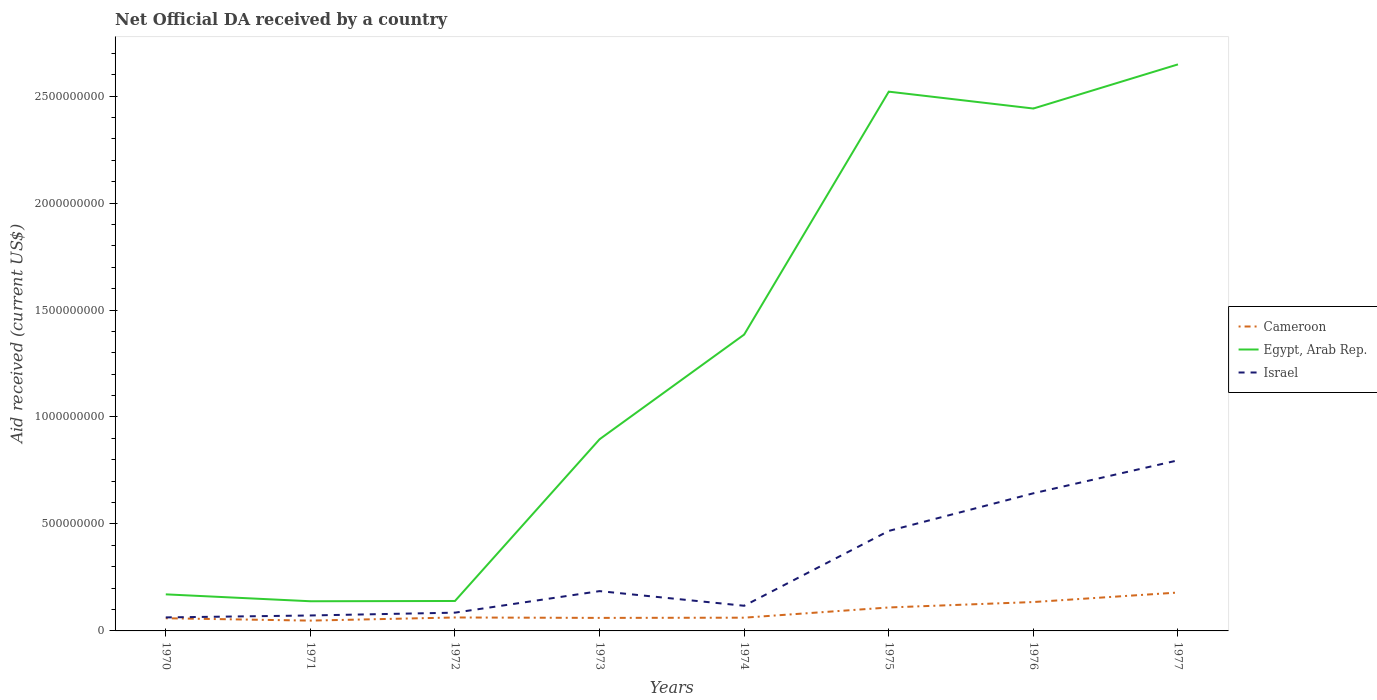Does the line corresponding to Egypt, Arab Rep. intersect with the line corresponding to Israel?
Provide a succinct answer. No. Is the number of lines equal to the number of legend labels?
Offer a very short reply. Yes. Across all years, what is the maximum net official development assistance aid received in Israel?
Offer a terse response. 6.32e+07. What is the total net official development assistance aid received in Cameroon in the graph?
Keep it short and to the point. -3.59e+06. What is the difference between the highest and the second highest net official development assistance aid received in Israel?
Provide a short and direct response. 7.34e+08. How many years are there in the graph?
Offer a very short reply. 8. Are the values on the major ticks of Y-axis written in scientific E-notation?
Make the answer very short. No. What is the title of the graph?
Your response must be concise. Net Official DA received by a country. What is the label or title of the Y-axis?
Offer a terse response. Aid received (current US$). What is the Aid received (current US$) in Cameroon in 1970?
Ensure brevity in your answer.  5.93e+07. What is the Aid received (current US$) of Egypt, Arab Rep. in 1970?
Give a very brief answer. 1.71e+08. What is the Aid received (current US$) of Israel in 1970?
Provide a succinct answer. 6.32e+07. What is the Aid received (current US$) of Cameroon in 1971?
Offer a very short reply. 4.82e+07. What is the Aid received (current US$) in Egypt, Arab Rep. in 1971?
Make the answer very short. 1.39e+08. What is the Aid received (current US$) in Israel in 1971?
Your answer should be compact. 7.22e+07. What is the Aid received (current US$) of Cameroon in 1972?
Provide a succinct answer. 6.29e+07. What is the Aid received (current US$) of Egypt, Arab Rep. in 1972?
Your answer should be very brief. 1.40e+08. What is the Aid received (current US$) of Israel in 1972?
Provide a short and direct response. 8.54e+07. What is the Aid received (current US$) in Cameroon in 1973?
Offer a very short reply. 6.09e+07. What is the Aid received (current US$) of Egypt, Arab Rep. in 1973?
Provide a short and direct response. 8.96e+08. What is the Aid received (current US$) in Israel in 1973?
Ensure brevity in your answer.  1.86e+08. What is the Aid received (current US$) in Cameroon in 1974?
Offer a terse response. 6.19e+07. What is the Aid received (current US$) in Egypt, Arab Rep. in 1974?
Provide a short and direct response. 1.39e+09. What is the Aid received (current US$) in Israel in 1974?
Your response must be concise. 1.18e+08. What is the Aid received (current US$) in Cameroon in 1975?
Keep it short and to the point. 1.10e+08. What is the Aid received (current US$) of Egypt, Arab Rep. in 1975?
Offer a very short reply. 2.52e+09. What is the Aid received (current US$) in Israel in 1975?
Keep it short and to the point. 4.67e+08. What is the Aid received (current US$) of Cameroon in 1976?
Keep it short and to the point. 1.35e+08. What is the Aid received (current US$) of Egypt, Arab Rep. in 1976?
Your answer should be compact. 2.44e+09. What is the Aid received (current US$) of Israel in 1976?
Give a very brief answer. 6.43e+08. What is the Aid received (current US$) in Cameroon in 1977?
Make the answer very short. 1.79e+08. What is the Aid received (current US$) of Egypt, Arab Rep. in 1977?
Offer a very short reply. 2.65e+09. What is the Aid received (current US$) of Israel in 1977?
Your answer should be very brief. 7.97e+08. Across all years, what is the maximum Aid received (current US$) in Cameroon?
Ensure brevity in your answer.  1.79e+08. Across all years, what is the maximum Aid received (current US$) in Egypt, Arab Rep.?
Your response must be concise. 2.65e+09. Across all years, what is the maximum Aid received (current US$) in Israel?
Make the answer very short. 7.97e+08. Across all years, what is the minimum Aid received (current US$) of Cameroon?
Make the answer very short. 4.82e+07. Across all years, what is the minimum Aid received (current US$) in Egypt, Arab Rep.?
Ensure brevity in your answer.  1.39e+08. Across all years, what is the minimum Aid received (current US$) of Israel?
Your response must be concise. 6.32e+07. What is the total Aid received (current US$) in Cameroon in the graph?
Ensure brevity in your answer.  7.17e+08. What is the total Aid received (current US$) of Egypt, Arab Rep. in the graph?
Keep it short and to the point. 1.03e+1. What is the total Aid received (current US$) in Israel in the graph?
Your response must be concise. 2.43e+09. What is the difference between the Aid received (current US$) in Cameroon in 1970 and that in 1971?
Offer a very short reply. 1.11e+07. What is the difference between the Aid received (current US$) of Egypt, Arab Rep. in 1970 and that in 1971?
Ensure brevity in your answer.  3.22e+07. What is the difference between the Aid received (current US$) of Israel in 1970 and that in 1971?
Offer a very short reply. -9.06e+06. What is the difference between the Aid received (current US$) in Cameroon in 1970 and that in 1972?
Offer a terse response. -3.59e+06. What is the difference between the Aid received (current US$) in Egypt, Arab Rep. in 1970 and that in 1972?
Your answer should be compact. 3.10e+07. What is the difference between the Aid received (current US$) in Israel in 1970 and that in 1972?
Your answer should be very brief. -2.22e+07. What is the difference between the Aid received (current US$) of Cameroon in 1970 and that in 1973?
Provide a short and direct response. -1.61e+06. What is the difference between the Aid received (current US$) of Egypt, Arab Rep. in 1970 and that in 1973?
Offer a very short reply. -7.25e+08. What is the difference between the Aid received (current US$) of Israel in 1970 and that in 1973?
Give a very brief answer. -1.23e+08. What is the difference between the Aid received (current US$) of Cameroon in 1970 and that in 1974?
Your answer should be very brief. -2.62e+06. What is the difference between the Aid received (current US$) of Egypt, Arab Rep. in 1970 and that in 1974?
Ensure brevity in your answer.  -1.21e+09. What is the difference between the Aid received (current US$) of Israel in 1970 and that in 1974?
Your response must be concise. -5.44e+07. What is the difference between the Aid received (current US$) in Cameroon in 1970 and that in 1975?
Give a very brief answer. -5.04e+07. What is the difference between the Aid received (current US$) in Egypt, Arab Rep. in 1970 and that in 1975?
Your answer should be very brief. -2.35e+09. What is the difference between the Aid received (current US$) of Israel in 1970 and that in 1975?
Ensure brevity in your answer.  -4.04e+08. What is the difference between the Aid received (current US$) of Cameroon in 1970 and that in 1976?
Provide a short and direct response. -7.58e+07. What is the difference between the Aid received (current US$) in Egypt, Arab Rep. in 1970 and that in 1976?
Make the answer very short. -2.27e+09. What is the difference between the Aid received (current US$) in Israel in 1970 and that in 1976?
Provide a succinct answer. -5.80e+08. What is the difference between the Aid received (current US$) in Cameroon in 1970 and that in 1977?
Give a very brief answer. -1.20e+08. What is the difference between the Aid received (current US$) in Egypt, Arab Rep. in 1970 and that in 1977?
Provide a succinct answer. -2.48e+09. What is the difference between the Aid received (current US$) of Israel in 1970 and that in 1977?
Keep it short and to the point. -7.34e+08. What is the difference between the Aid received (current US$) in Cameroon in 1971 and that in 1972?
Offer a terse response. -1.47e+07. What is the difference between the Aid received (current US$) of Egypt, Arab Rep. in 1971 and that in 1972?
Provide a succinct answer. -1.23e+06. What is the difference between the Aid received (current US$) of Israel in 1971 and that in 1972?
Offer a very short reply. -1.32e+07. What is the difference between the Aid received (current US$) in Cameroon in 1971 and that in 1973?
Keep it short and to the point. -1.27e+07. What is the difference between the Aid received (current US$) of Egypt, Arab Rep. in 1971 and that in 1973?
Provide a succinct answer. -7.57e+08. What is the difference between the Aid received (current US$) in Israel in 1971 and that in 1973?
Offer a very short reply. -1.14e+08. What is the difference between the Aid received (current US$) in Cameroon in 1971 and that in 1974?
Give a very brief answer. -1.37e+07. What is the difference between the Aid received (current US$) in Egypt, Arab Rep. in 1971 and that in 1974?
Keep it short and to the point. -1.25e+09. What is the difference between the Aid received (current US$) of Israel in 1971 and that in 1974?
Your answer should be compact. -4.54e+07. What is the difference between the Aid received (current US$) in Cameroon in 1971 and that in 1975?
Ensure brevity in your answer.  -6.14e+07. What is the difference between the Aid received (current US$) in Egypt, Arab Rep. in 1971 and that in 1975?
Ensure brevity in your answer.  -2.38e+09. What is the difference between the Aid received (current US$) in Israel in 1971 and that in 1975?
Make the answer very short. -3.95e+08. What is the difference between the Aid received (current US$) in Cameroon in 1971 and that in 1976?
Give a very brief answer. -8.69e+07. What is the difference between the Aid received (current US$) in Egypt, Arab Rep. in 1971 and that in 1976?
Offer a very short reply. -2.30e+09. What is the difference between the Aid received (current US$) in Israel in 1971 and that in 1976?
Provide a succinct answer. -5.71e+08. What is the difference between the Aid received (current US$) in Cameroon in 1971 and that in 1977?
Your response must be concise. -1.31e+08. What is the difference between the Aid received (current US$) in Egypt, Arab Rep. in 1971 and that in 1977?
Offer a very short reply. -2.51e+09. What is the difference between the Aid received (current US$) in Israel in 1971 and that in 1977?
Offer a terse response. -7.25e+08. What is the difference between the Aid received (current US$) of Cameroon in 1972 and that in 1973?
Give a very brief answer. 1.98e+06. What is the difference between the Aid received (current US$) in Egypt, Arab Rep. in 1972 and that in 1973?
Offer a very short reply. -7.56e+08. What is the difference between the Aid received (current US$) of Israel in 1972 and that in 1973?
Offer a terse response. -1.01e+08. What is the difference between the Aid received (current US$) of Cameroon in 1972 and that in 1974?
Your response must be concise. 9.70e+05. What is the difference between the Aid received (current US$) of Egypt, Arab Rep. in 1972 and that in 1974?
Give a very brief answer. -1.25e+09. What is the difference between the Aid received (current US$) in Israel in 1972 and that in 1974?
Your answer should be compact. -3.22e+07. What is the difference between the Aid received (current US$) in Cameroon in 1972 and that in 1975?
Provide a succinct answer. -4.68e+07. What is the difference between the Aid received (current US$) of Egypt, Arab Rep. in 1972 and that in 1975?
Give a very brief answer. -2.38e+09. What is the difference between the Aid received (current US$) in Israel in 1972 and that in 1975?
Keep it short and to the point. -3.82e+08. What is the difference between the Aid received (current US$) of Cameroon in 1972 and that in 1976?
Ensure brevity in your answer.  -7.22e+07. What is the difference between the Aid received (current US$) in Egypt, Arab Rep. in 1972 and that in 1976?
Your answer should be compact. -2.30e+09. What is the difference between the Aid received (current US$) of Israel in 1972 and that in 1976?
Keep it short and to the point. -5.58e+08. What is the difference between the Aid received (current US$) in Cameroon in 1972 and that in 1977?
Offer a terse response. -1.17e+08. What is the difference between the Aid received (current US$) in Egypt, Arab Rep. in 1972 and that in 1977?
Your answer should be very brief. -2.51e+09. What is the difference between the Aid received (current US$) of Israel in 1972 and that in 1977?
Your answer should be compact. -7.12e+08. What is the difference between the Aid received (current US$) in Cameroon in 1973 and that in 1974?
Your response must be concise. -1.01e+06. What is the difference between the Aid received (current US$) of Egypt, Arab Rep. in 1973 and that in 1974?
Provide a succinct answer. -4.89e+08. What is the difference between the Aid received (current US$) of Israel in 1973 and that in 1974?
Provide a short and direct response. 6.84e+07. What is the difference between the Aid received (current US$) in Cameroon in 1973 and that in 1975?
Ensure brevity in your answer.  -4.87e+07. What is the difference between the Aid received (current US$) in Egypt, Arab Rep. in 1973 and that in 1975?
Provide a short and direct response. -1.62e+09. What is the difference between the Aid received (current US$) of Israel in 1973 and that in 1975?
Provide a succinct answer. -2.81e+08. What is the difference between the Aid received (current US$) in Cameroon in 1973 and that in 1976?
Your answer should be compact. -7.42e+07. What is the difference between the Aid received (current US$) of Egypt, Arab Rep. in 1973 and that in 1976?
Provide a short and direct response. -1.55e+09. What is the difference between the Aid received (current US$) of Israel in 1973 and that in 1976?
Provide a short and direct response. -4.57e+08. What is the difference between the Aid received (current US$) in Cameroon in 1973 and that in 1977?
Offer a terse response. -1.19e+08. What is the difference between the Aid received (current US$) in Egypt, Arab Rep. in 1973 and that in 1977?
Make the answer very short. -1.75e+09. What is the difference between the Aid received (current US$) in Israel in 1973 and that in 1977?
Provide a succinct answer. -6.11e+08. What is the difference between the Aid received (current US$) in Cameroon in 1974 and that in 1975?
Offer a terse response. -4.77e+07. What is the difference between the Aid received (current US$) of Egypt, Arab Rep. in 1974 and that in 1975?
Your response must be concise. -1.14e+09. What is the difference between the Aid received (current US$) in Israel in 1974 and that in 1975?
Keep it short and to the point. -3.50e+08. What is the difference between the Aid received (current US$) of Cameroon in 1974 and that in 1976?
Offer a very short reply. -7.32e+07. What is the difference between the Aid received (current US$) of Egypt, Arab Rep. in 1974 and that in 1976?
Give a very brief answer. -1.06e+09. What is the difference between the Aid received (current US$) in Israel in 1974 and that in 1976?
Offer a very short reply. -5.26e+08. What is the difference between the Aid received (current US$) of Cameroon in 1974 and that in 1977?
Give a very brief answer. -1.18e+08. What is the difference between the Aid received (current US$) in Egypt, Arab Rep. in 1974 and that in 1977?
Your answer should be very brief. -1.26e+09. What is the difference between the Aid received (current US$) in Israel in 1974 and that in 1977?
Ensure brevity in your answer.  -6.80e+08. What is the difference between the Aid received (current US$) in Cameroon in 1975 and that in 1976?
Give a very brief answer. -2.54e+07. What is the difference between the Aid received (current US$) of Egypt, Arab Rep. in 1975 and that in 1976?
Provide a short and direct response. 7.89e+07. What is the difference between the Aid received (current US$) in Israel in 1975 and that in 1976?
Your answer should be compact. -1.76e+08. What is the difference between the Aid received (current US$) of Cameroon in 1975 and that in 1977?
Offer a terse response. -6.98e+07. What is the difference between the Aid received (current US$) of Egypt, Arab Rep. in 1975 and that in 1977?
Make the answer very short. -1.27e+08. What is the difference between the Aid received (current US$) of Israel in 1975 and that in 1977?
Your answer should be compact. -3.30e+08. What is the difference between the Aid received (current US$) in Cameroon in 1976 and that in 1977?
Make the answer very short. -4.44e+07. What is the difference between the Aid received (current US$) of Egypt, Arab Rep. in 1976 and that in 1977?
Keep it short and to the point. -2.06e+08. What is the difference between the Aid received (current US$) of Israel in 1976 and that in 1977?
Your answer should be compact. -1.54e+08. What is the difference between the Aid received (current US$) of Cameroon in 1970 and the Aid received (current US$) of Egypt, Arab Rep. in 1971?
Provide a succinct answer. -7.94e+07. What is the difference between the Aid received (current US$) in Cameroon in 1970 and the Aid received (current US$) in Israel in 1971?
Offer a very short reply. -1.30e+07. What is the difference between the Aid received (current US$) in Egypt, Arab Rep. in 1970 and the Aid received (current US$) in Israel in 1971?
Keep it short and to the point. 9.87e+07. What is the difference between the Aid received (current US$) of Cameroon in 1970 and the Aid received (current US$) of Egypt, Arab Rep. in 1972?
Make the answer very short. -8.07e+07. What is the difference between the Aid received (current US$) of Cameroon in 1970 and the Aid received (current US$) of Israel in 1972?
Give a very brief answer. -2.61e+07. What is the difference between the Aid received (current US$) in Egypt, Arab Rep. in 1970 and the Aid received (current US$) in Israel in 1972?
Your answer should be very brief. 8.56e+07. What is the difference between the Aid received (current US$) in Cameroon in 1970 and the Aid received (current US$) in Egypt, Arab Rep. in 1973?
Ensure brevity in your answer.  -8.37e+08. What is the difference between the Aid received (current US$) in Cameroon in 1970 and the Aid received (current US$) in Israel in 1973?
Your answer should be very brief. -1.27e+08. What is the difference between the Aid received (current US$) in Egypt, Arab Rep. in 1970 and the Aid received (current US$) in Israel in 1973?
Your answer should be very brief. -1.51e+07. What is the difference between the Aid received (current US$) of Cameroon in 1970 and the Aid received (current US$) of Egypt, Arab Rep. in 1974?
Offer a very short reply. -1.33e+09. What is the difference between the Aid received (current US$) in Cameroon in 1970 and the Aid received (current US$) in Israel in 1974?
Your response must be concise. -5.83e+07. What is the difference between the Aid received (current US$) of Egypt, Arab Rep. in 1970 and the Aid received (current US$) of Israel in 1974?
Offer a terse response. 5.34e+07. What is the difference between the Aid received (current US$) in Cameroon in 1970 and the Aid received (current US$) in Egypt, Arab Rep. in 1975?
Your response must be concise. -2.46e+09. What is the difference between the Aid received (current US$) of Cameroon in 1970 and the Aid received (current US$) of Israel in 1975?
Provide a short and direct response. -4.08e+08. What is the difference between the Aid received (current US$) of Egypt, Arab Rep. in 1970 and the Aid received (current US$) of Israel in 1975?
Provide a succinct answer. -2.97e+08. What is the difference between the Aid received (current US$) of Cameroon in 1970 and the Aid received (current US$) of Egypt, Arab Rep. in 1976?
Offer a terse response. -2.38e+09. What is the difference between the Aid received (current US$) of Cameroon in 1970 and the Aid received (current US$) of Israel in 1976?
Provide a short and direct response. -5.84e+08. What is the difference between the Aid received (current US$) in Egypt, Arab Rep. in 1970 and the Aid received (current US$) in Israel in 1976?
Offer a very short reply. -4.72e+08. What is the difference between the Aid received (current US$) of Cameroon in 1970 and the Aid received (current US$) of Egypt, Arab Rep. in 1977?
Keep it short and to the point. -2.59e+09. What is the difference between the Aid received (current US$) in Cameroon in 1970 and the Aid received (current US$) in Israel in 1977?
Keep it short and to the point. -7.38e+08. What is the difference between the Aid received (current US$) of Egypt, Arab Rep. in 1970 and the Aid received (current US$) of Israel in 1977?
Ensure brevity in your answer.  -6.26e+08. What is the difference between the Aid received (current US$) in Cameroon in 1971 and the Aid received (current US$) in Egypt, Arab Rep. in 1972?
Provide a succinct answer. -9.18e+07. What is the difference between the Aid received (current US$) of Cameroon in 1971 and the Aid received (current US$) of Israel in 1972?
Keep it short and to the point. -3.72e+07. What is the difference between the Aid received (current US$) of Egypt, Arab Rep. in 1971 and the Aid received (current US$) of Israel in 1972?
Your response must be concise. 5.33e+07. What is the difference between the Aid received (current US$) of Cameroon in 1971 and the Aid received (current US$) of Egypt, Arab Rep. in 1973?
Offer a very short reply. -8.48e+08. What is the difference between the Aid received (current US$) in Cameroon in 1971 and the Aid received (current US$) in Israel in 1973?
Make the answer very short. -1.38e+08. What is the difference between the Aid received (current US$) of Egypt, Arab Rep. in 1971 and the Aid received (current US$) of Israel in 1973?
Make the answer very short. -4.73e+07. What is the difference between the Aid received (current US$) in Cameroon in 1971 and the Aid received (current US$) in Egypt, Arab Rep. in 1974?
Your answer should be compact. -1.34e+09. What is the difference between the Aid received (current US$) of Cameroon in 1971 and the Aid received (current US$) of Israel in 1974?
Provide a succinct answer. -6.94e+07. What is the difference between the Aid received (current US$) in Egypt, Arab Rep. in 1971 and the Aid received (current US$) in Israel in 1974?
Provide a short and direct response. 2.11e+07. What is the difference between the Aid received (current US$) in Cameroon in 1971 and the Aid received (current US$) in Egypt, Arab Rep. in 1975?
Offer a terse response. -2.47e+09. What is the difference between the Aid received (current US$) in Cameroon in 1971 and the Aid received (current US$) in Israel in 1975?
Provide a short and direct response. -4.19e+08. What is the difference between the Aid received (current US$) of Egypt, Arab Rep. in 1971 and the Aid received (current US$) of Israel in 1975?
Keep it short and to the point. -3.29e+08. What is the difference between the Aid received (current US$) of Cameroon in 1971 and the Aid received (current US$) of Egypt, Arab Rep. in 1976?
Give a very brief answer. -2.39e+09. What is the difference between the Aid received (current US$) in Cameroon in 1971 and the Aid received (current US$) in Israel in 1976?
Keep it short and to the point. -5.95e+08. What is the difference between the Aid received (current US$) of Egypt, Arab Rep. in 1971 and the Aid received (current US$) of Israel in 1976?
Provide a succinct answer. -5.05e+08. What is the difference between the Aid received (current US$) in Cameroon in 1971 and the Aid received (current US$) in Egypt, Arab Rep. in 1977?
Provide a short and direct response. -2.60e+09. What is the difference between the Aid received (current US$) of Cameroon in 1971 and the Aid received (current US$) of Israel in 1977?
Give a very brief answer. -7.49e+08. What is the difference between the Aid received (current US$) of Egypt, Arab Rep. in 1971 and the Aid received (current US$) of Israel in 1977?
Keep it short and to the point. -6.59e+08. What is the difference between the Aid received (current US$) in Cameroon in 1972 and the Aid received (current US$) in Egypt, Arab Rep. in 1973?
Provide a succinct answer. -8.33e+08. What is the difference between the Aid received (current US$) of Cameroon in 1972 and the Aid received (current US$) of Israel in 1973?
Provide a succinct answer. -1.23e+08. What is the difference between the Aid received (current US$) in Egypt, Arab Rep. in 1972 and the Aid received (current US$) in Israel in 1973?
Provide a succinct answer. -4.61e+07. What is the difference between the Aid received (current US$) in Cameroon in 1972 and the Aid received (current US$) in Egypt, Arab Rep. in 1974?
Provide a short and direct response. -1.32e+09. What is the difference between the Aid received (current US$) of Cameroon in 1972 and the Aid received (current US$) of Israel in 1974?
Your answer should be very brief. -5.47e+07. What is the difference between the Aid received (current US$) of Egypt, Arab Rep. in 1972 and the Aid received (current US$) of Israel in 1974?
Your answer should be very brief. 2.24e+07. What is the difference between the Aid received (current US$) of Cameroon in 1972 and the Aid received (current US$) of Egypt, Arab Rep. in 1975?
Your answer should be very brief. -2.46e+09. What is the difference between the Aid received (current US$) in Cameroon in 1972 and the Aid received (current US$) in Israel in 1975?
Provide a short and direct response. -4.05e+08. What is the difference between the Aid received (current US$) in Egypt, Arab Rep. in 1972 and the Aid received (current US$) in Israel in 1975?
Your response must be concise. -3.28e+08. What is the difference between the Aid received (current US$) of Cameroon in 1972 and the Aid received (current US$) of Egypt, Arab Rep. in 1976?
Make the answer very short. -2.38e+09. What is the difference between the Aid received (current US$) of Cameroon in 1972 and the Aid received (current US$) of Israel in 1976?
Ensure brevity in your answer.  -5.80e+08. What is the difference between the Aid received (current US$) in Egypt, Arab Rep. in 1972 and the Aid received (current US$) in Israel in 1976?
Give a very brief answer. -5.03e+08. What is the difference between the Aid received (current US$) in Cameroon in 1972 and the Aid received (current US$) in Egypt, Arab Rep. in 1977?
Make the answer very short. -2.59e+09. What is the difference between the Aid received (current US$) of Cameroon in 1972 and the Aid received (current US$) of Israel in 1977?
Offer a terse response. -7.35e+08. What is the difference between the Aid received (current US$) in Egypt, Arab Rep. in 1972 and the Aid received (current US$) in Israel in 1977?
Offer a terse response. -6.57e+08. What is the difference between the Aid received (current US$) in Cameroon in 1973 and the Aid received (current US$) in Egypt, Arab Rep. in 1974?
Provide a short and direct response. -1.32e+09. What is the difference between the Aid received (current US$) of Cameroon in 1973 and the Aid received (current US$) of Israel in 1974?
Ensure brevity in your answer.  -5.67e+07. What is the difference between the Aid received (current US$) of Egypt, Arab Rep. in 1973 and the Aid received (current US$) of Israel in 1974?
Offer a very short reply. 7.78e+08. What is the difference between the Aid received (current US$) in Cameroon in 1973 and the Aid received (current US$) in Egypt, Arab Rep. in 1975?
Provide a short and direct response. -2.46e+09. What is the difference between the Aid received (current US$) of Cameroon in 1973 and the Aid received (current US$) of Israel in 1975?
Give a very brief answer. -4.07e+08. What is the difference between the Aid received (current US$) in Egypt, Arab Rep. in 1973 and the Aid received (current US$) in Israel in 1975?
Ensure brevity in your answer.  4.28e+08. What is the difference between the Aid received (current US$) in Cameroon in 1973 and the Aid received (current US$) in Egypt, Arab Rep. in 1976?
Provide a succinct answer. -2.38e+09. What is the difference between the Aid received (current US$) in Cameroon in 1973 and the Aid received (current US$) in Israel in 1976?
Your answer should be compact. -5.82e+08. What is the difference between the Aid received (current US$) of Egypt, Arab Rep. in 1973 and the Aid received (current US$) of Israel in 1976?
Your answer should be very brief. 2.53e+08. What is the difference between the Aid received (current US$) of Cameroon in 1973 and the Aid received (current US$) of Egypt, Arab Rep. in 1977?
Make the answer very short. -2.59e+09. What is the difference between the Aid received (current US$) of Cameroon in 1973 and the Aid received (current US$) of Israel in 1977?
Make the answer very short. -7.37e+08. What is the difference between the Aid received (current US$) in Egypt, Arab Rep. in 1973 and the Aid received (current US$) in Israel in 1977?
Give a very brief answer. 9.85e+07. What is the difference between the Aid received (current US$) in Cameroon in 1974 and the Aid received (current US$) in Egypt, Arab Rep. in 1975?
Keep it short and to the point. -2.46e+09. What is the difference between the Aid received (current US$) of Cameroon in 1974 and the Aid received (current US$) of Israel in 1975?
Ensure brevity in your answer.  -4.06e+08. What is the difference between the Aid received (current US$) of Egypt, Arab Rep. in 1974 and the Aid received (current US$) of Israel in 1975?
Provide a succinct answer. 9.18e+08. What is the difference between the Aid received (current US$) in Cameroon in 1974 and the Aid received (current US$) in Egypt, Arab Rep. in 1976?
Keep it short and to the point. -2.38e+09. What is the difference between the Aid received (current US$) of Cameroon in 1974 and the Aid received (current US$) of Israel in 1976?
Offer a terse response. -5.81e+08. What is the difference between the Aid received (current US$) of Egypt, Arab Rep. in 1974 and the Aid received (current US$) of Israel in 1976?
Keep it short and to the point. 7.42e+08. What is the difference between the Aid received (current US$) of Cameroon in 1974 and the Aid received (current US$) of Egypt, Arab Rep. in 1977?
Keep it short and to the point. -2.59e+09. What is the difference between the Aid received (current US$) in Cameroon in 1974 and the Aid received (current US$) in Israel in 1977?
Keep it short and to the point. -7.36e+08. What is the difference between the Aid received (current US$) in Egypt, Arab Rep. in 1974 and the Aid received (current US$) in Israel in 1977?
Keep it short and to the point. 5.88e+08. What is the difference between the Aid received (current US$) of Cameroon in 1975 and the Aid received (current US$) of Egypt, Arab Rep. in 1976?
Provide a short and direct response. -2.33e+09. What is the difference between the Aid received (current US$) of Cameroon in 1975 and the Aid received (current US$) of Israel in 1976?
Provide a succinct answer. -5.34e+08. What is the difference between the Aid received (current US$) of Egypt, Arab Rep. in 1975 and the Aid received (current US$) of Israel in 1976?
Your answer should be very brief. 1.88e+09. What is the difference between the Aid received (current US$) in Cameroon in 1975 and the Aid received (current US$) in Egypt, Arab Rep. in 1977?
Your answer should be compact. -2.54e+09. What is the difference between the Aid received (current US$) in Cameroon in 1975 and the Aid received (current US$) in Israel in 1977?
Ensure brevity in your answer.  -6.88e+08. What is the difference between the Aid received (current US$) of Egypt, Arab Rep. in 1975 and the Aid received (current US$) of Israel in 1977?
Keep it short and to the point. 1.72e+09. What is the difference between the Aid received (current US$) in Cameroon in 1976 and the Aid received (current US$) in Egypt, Arab Rep. in 1977?
Give a very brief answer. -2.51e+09. What is the difference between the Aid received (current US$) in Cameroon in 1976 and the Aid received (current US$) in Israel in 1977?
Your response must be concise. -6.62e+08. What is the difference between the Aid received (current US$) of Egypt, Arab Rep. in 1976 and the Aid received (current US$) of Israel in 1977?
Your answer should be compact. 1.64e+09. What is the average Aid received (current US$) in Cameroon per year?
Provide a succinct answer. 8.96e+07. What is the average Aid received (current US$) in Egypt, Arab Rep. per year?
Make the answer very short. 1.29e+09. What is the average Aid received (current US$) in Israel per year?
Make the answer very short. 3.04e+08. In the year 1970, what is the difference between the Aid received (current US$) of Cameroon and Aid received (current US$) of Egypt, Arab Rep.?
Make the answer very short. -1.12e+08. In the year 1970, what is the difference between the Aid received (current US$) of Cameroon and Aid received (current US$) of Israel?
Your answer should be compact. -3.89e+06. In the year 1970, what is the difference between the Aid received (current US$) of Egypt, Arab Rep. and Aid received (current US$) of Israel?
Your answer should be very brief. 1.08e+08. In the year 1971, what is the difference between the Aid received (current US$) of Cameroon and Aid received (current US$) of Egypt, Arab Rep.?
Provide a succinct answer. -9.05e+07. In the year 1971, what is the difference between the Aid received (current US$) in Cameroon and Aid received (current US$) in Israel?
Your answer should be compact. -2.40e+07. In the year 1971, what is the difference between the Aid received (current US$) in Egypt, Arab Rep. and Aid received (current US$) in Israel?
Make the answer very short. 6.65e+07. In the year 1972, what is the difference between the Aid received (current US$) of Cameroon and Aid received (current US$) of Egypt, Arab Rep.?
Provide a succinct answer. -7.71e+07. In the year 1972, what is the difference between the Aid received (current US$) of Cameroon and Aid received (current US$) of Israel?
Your answer should be very brief. -2.25e+07. In the year 1972, what is the difference between the Aid received (current US$) in Egypt, Arab Rep. and Aid received (current US$) in Israel?
Provide a short and direct response. 5.46e+07. In the year 1973, what is the difference between the Aid received (current US$) in Cameroon and Aid received (current US$) in Egypt, Arab Rep.?
Ensure brevity in your answer.  -8.35e+08. In the year 1973, what is the difference between the Aid received (current US$) in Cameroon and Aid received (current US$) in Israel?
Your answer should be compact. -1.25e+08. In the year 1973, what is the difference between the Aid received (current US$) in Egypt, Arab Rep. and Aid received (current US$) in Israel?
Provide a short and direct response. 7.10e+08. In the year 1974, what is the difference between the Aid received (current US$) of Cameroon and Aid received (current US$) of Egypt, Arab Rep.?
Keep it short and to the point. -1.32e+09. In the year 1974, what is the difference between the Aid received (current US$) in Cameroon and Aid received (current US$) in Israel?
Offer a terse response. -5.57e+07. In the year 1974, what is the difference between the Aid received (current US$) of Egypt, Arab Rep. and Aid received (current US$) of Israel?
Make the answer very short. 1.27e+09. In the year 1975, what is the difference between the Aid received (current US$) in Cameroon and Aid received (current US$) in Egypt, Arab Rep.?
Your response must be concise. -2.41e+09. In the year 1975, what is the difference between the Aid received (current US$) in Cameroon and Aid received (current US$) in Israel?
Ensure brevity in your answer.  -3.58e+08. In the year 1975, what is the difference between the Aid received (current US$) in Egypt, Arab Rep. and Aid received (current US$) in Israel?
Provide a short and direct response. 2.05e+09. In the year 1976, what is the difference between the Aid received (current US$) in Cameroon and Aid received (current US$) in Egypt, Arab Rep.?
Make the answer very short. -2.31e+09. In the year 1976, what is the difference between the Aid received (current US$) of Cameroon and Aid received (current US$) of Israel?
Provide a succinct answer. -5.08e+08. In the year 1976, what is the difference between the Aid received (current US$) of Egypt, Arab Rep. and Aid received (current US$) of Israel?
Offer a very short reply. 1.80e+09. In the year 1977, what is the difference between the Aid received (current US$) of Cameroon and Aid received (current US$) of Egypt, Arab Rep.?
Give a very brief answer. -2.47e+09. In the year 1977, what is the difference between the Aid received (current US$) in Cameroon and Aid received (current US$) in Israel?
Provide a succinct answer. -6.18e+08. In the year 1977, what is the difference between the Aid received (current US$) of Egypt, Arab Rep. and Aid received (current US$) of Israel?
Keep it short and to the point. 1.85e+09. What is the ratio of the Aid received (current US$) in Cameroon in 1970 to that in 1971?
Provide a succinct answer. 1.23. What is the ratio of the Aid received (current US$) in Egypt, Arab Rep. in 1970 to that in 1971?
Give a very brief answer. 1.23. What is the ratio of the Aid received (current US$) in Israel in 1970 to that in 1971?
Your answer should be very brief. 0.87. What is the ratio of the Aid received (current US$) of Cameroon in 1970 to that in 1972?
Provide a short and direct response. 0.94. What is the ratio of the Aid received (current US$) of Egypt, Arab Rep. in 1970 to that in 1972?
Your response must be concise. 1.22. What is the ratio of the Aid received (current US$) in Israel in 1970 to that in 1972?
Keep it short and to the point. 0.74. What is the ratio of the Aid received (current US$) in Cameroon in 1970 to that in 1973?
Offer a very short reply. 0.97. What is the ratio of the Aid received (current US$) of Egypt, Arab Rep. in 1970 to that in 1973?
Provide a short and direct response. 0.19. What is the ratio of the Aid received (current US$) of Israel in 1970 to that in 1973?
Offer a very short reply. 0.34. What is the ratio of the Aid received (current US$) of Cameroon in 1970 to that in 1974?
Provide a short and direct response. 0.96. What is the ratio of the Aid received (current US$) of Egypt, Arab Rep. in 1970 to that in 1974?
Provide a short and direct response. 0.12. What is the ratio of the Aid received (current US$) of Israel in 1970 to that in 1974?
Your answer should be compact. 0.54. What is the ratio of the Aid received (current US$) of Cameroon in 1970 to that in 1975?
Offer a terse response. 0.54. What is the ratio of the Aid received (current US$) of Egypt, Arab Rep. in 1970 to that in 1975?
Keep it short and to the point. 0.07. What is the ratio of the Aid received (current US$) in Israel in 1970 to that in 1975?
Give a very brief answer. 0.14. What is the ratio of the Aid received (current US$) in Cameroon in 1970 to that in 1976?
Your response must be concise. 0.44. What is the ratio of the Aid received (current US$) of Egypt, Arab Rep. in 1970 to that in 1976?
Provide a succinct answer. 0.07. What is the ratio of the Aid received (current US$) in Israel in 1970 to that in 1976?
Your response must be concise. 0.1. What is the ratio of the Aid received (current US$) of Cameroon in 1970 to that in 1977?
Make the answer very short. 0.33. What is the ratio of the Aid received (current US$) in Egypt, Arab Rep. in 1970 to that in 1977?
Give a very brief answer. 0.06. What is the ratio of the Aid received (current US$) in Israel in 1970 to that in 1977?
Your response must be concise. 0.08. What is the ratio of the Aid received (current US$) in Cameroon in 1971 to that in 1972?
Keep it short and to the point. 0.77. What is the ratio of the Aid received (current US$) of Israel in 1971 to that in 1972?
Make the answer very short. 0.85. What is the ratio of the Aid received (current US$) in Cameroon in 1971 to that in 1973?
Keep it short and to the point. 0.79. What is the ratio of the Aid received (current US$) of Egypt, Arab Rep. in 1971 to that in 1973?
Ensure brevity in your answer.  0.15. What is the ratio of the Aid received (current US$) of Israel in 1971 to that in 1973?
Provide a succinct answer. 0.39. What is the ratio of the Aid received (current US$) of Cameroon in 1971 to that in 1974?
Your response must be concise. 0.78. What is the ratio of the Aid received (current US$) in Egypt, Arab Rep. in 1971 to that in 1974?
Make the answer very short. 0.1. What is the ratio of the Aid received (current US$) of Israel in 1971 to that in 1974?
Ensure brevity in your answer.  0.61. What is the ratio of the Aid received (current US$) of Cameroon in 1971 to that in 1975?
Provide a short and direct response. 0.44. What is the ratio of the Aid received (current US$) of Egypt, Arab Rep. in 1971 to that in 1975?
Provide a short and direct response. 0.06. What is the ratio of the Aid received (current US$) in Israel in 1971 to that in 1975?
Your answer should be compact. 0.15. What is the ratio of the Aid received (current US$) of Cameroon in 1971 to that in 1976?
Ensure brevity in your answer.  0.36. What is the ratio of the Aid received (current US$) in Egypt, Arab Rep. in 1971 to that in 1976?
Provide a succinct answer. 0.06. What is the ratio of the Aid received (current US$) of Israel in 1971 to that in 1976?
Make the answer very short. 0.11. What is the ratio of the Aid received (current US$) of Cameroon in 1971 to that in 1977?
Your answer should be very brief. 0.27. What is the ratio of the Aid received (current US$) of Egypt, Arab Rep. in 1971 to that in 1977?
Provide a short and direct response. 0.05. What is the ratio of the Aid received (current US$) in Israel in 1971 to that in 1977?
Your answer should be very brief. 0.09. What is the ratio of the Aid received (current US$) of Cameroon in 1972 to that in 1973?
Make the answer very short. 1.03. What is the ratio of the Aid received (current US$) of Egypt, Arab Rep. in 1972 to that in 1973?
Offer a terse response. 0.16. What is the ratio of the Aid received (current US$) of Israel in 1972 to that in 1973?
Ensure brevity in your answer.  0.46. What is the ratio of the Aid received (current US$) of Cameroon in 1972 to that in 1974?
Your answer should be compact. 1.02. What is the ratio of the Aid received (current US$) in Egypt, Arab Rep. in 1972 to that in 1974?
Ensure brevity in your answer.  0.1. What is the ratio of the Aid received (current US$) in Israel in 1972 to that in 1974?
Give a very brief answer. 0.73. What is the ratio of the Aid received (current US$) of Cameroon in 1972 to that in 1975?
Offer a very short reply. 0.57. What is the ratio of the Aid received (current US$) in Egypt, Arab Rep. in 1972 to that in 1975?
Make the answer very short. 0.06. What is the ratio of the Aid received (current US$) in Israel in 1972 to that in 1975?
Ensure brevity in your answer.  0.18. What is the ratio of the Aid received (current US$) in Cameroon in 1972 to that in 1976?
Provide a short and direct response. 0.47. What is the ratio of the Aid received (current US$) in Egypt, Arab Rep. in 1972 to that in 1976?
Keep it short and to the point. 0.06. What is the ratio of the Aid received (current US$) of Israel in 1972 to that in 1976?
Offer a very short reply. 0.13. What is the ratio of the Aid received (current US$) of Cameroon in 1972 to that in 1977?
Make the answer very short. 0.35. What is the ratio of the Aid received (current US$) in Egypt, Arab Rep. in 1972 to that in 1977?
Provide a succinct answer. 0.05. What is the ratio of the Aid received (current US$) in Israel in 1972 to that in 1977?
Your answer should be compact. 0.11. What is the ratio of the Aid received (current US$) of Cameroon in 1973 to that in 1974?
Your answer should be very brief. 0.98. What is the ratio of the Aid received (current US$) in Egypt, Arab Rep. in 1973 to that in 1974?
Make the answer very short. 0.65. What is the ratio of the Aid received (current US$) in Israel in 1973 to that in 1974?
Your answer should be compact. 1.58. What is the ratio of the Aid received (current US$) of Cameroon in 1973 to that in 1975?
Offer a terse response. 0.56. What is the ratio of the Aid received (current US$) in Egypt, Arab Rep. in 1973 to that in 1975?
Your answer should be compact. 0.36. What is the ratio of the Aid received (current US$) of Israel in 1973 to that in 1975?
Your answer should be compact. 0.4. What is the ratio of the Aid received (current US$) in Cameroon in 1973 to that in 1976?
Your answer should be compact. 0.45. What is the ratio of the Aid received (current US$) of Egypt, Arab Rep. in 1973 to that in 1976?
Keep it short and to the point. 0.37. What is the ratio of the Aid received (current US$) of Israel in 1973 to that in 1976?
Give a very brief answer. 0.29. What is the ratio of the Aid received (current US$) in Cameroon in 1973 to that in 1977?
Your answer should be very brief. 0.34. What is the ratio of the Aid received (current US$) of Egypt, Arab Rep. in 1973 to that in 1977?
Give a very brief answer. 0.34. What is the ratio of the Aid received (current US$) in Israel in 1973 to that in 1977?
Provide a succinct answer. 0.23. What is the ratio of the Aid received (current US$) of Cameroon in 1974 to that in 1975?
Make the answer very short. 0.56. What is the ratio of the Aid received (current US$) of Egypt, Arab Rep. in 1974 to that in 1975?
Keep it short and to the point. 0.55. What is the ratio of the Aid received (current US$) of Israel in 1974 to that in 1975?
Your response must be concise. 0.25. What is the ratio of the Aid received (current US$) of Cameroon in 1974 to that in 1976?
Keep it short and to the point. 0.46. What is the ratio of the Aid received (current US$) in Egypt, Arab Rep. in 1974 to that in 1976?
Make the answer very short. 0.57. What is the ratio of the Aid received (current US$) of Israel in 1974 to that in 1976?
Ensure brevity in your answer.  0.18. What is the ratio of the Aid received (current US$) in Cameroon in 1974 to that in 1977?
Your answer should be compact. 0.34. What is the ratio of the Aid received (current US$) in Egypt, Arab Rep. in 1974 to that in 1977?
Make the answer very short. 0.52. What is the ratio of the Aid received (current US$) in Israel in 1974 to that in 1977?
Your response must be concise. 0.15. What is the ratio of the Aid received (current US$) in Cameroon in 1975 to that in 1976?
Ensure brevity in your answer.  0.81. What is the ratio of the Aid received (current US$) in Egypt, Arab Rep. in 1975 to that in 1976?
Offer a very short reply. 1.03. What is the ratio of the Aid received (current US$) in Israel in 1975 to that in 1976?
Provide a succinct answer. 0.73. What is the ratio of the Aid received (current US$) of Cameroon in 1975 to that in 1977?
Your answer should be very brief. 0.61. What is the ratio of the Aid received (current US$) in Egypt, Arab Rep. in 1975 to that in 1977?
Give a very brief answer. 0.95. What is the ratio of the Aid received (current US$) in Israel in 1975 to that in 1977?
Your answer should be very brief. 0.59. What is the ratio of the Aid received (current US$) of Cameroon in 1976 to that in 1977?
Keep it short and to the point. 0.75. What is the ratio of the Aid received (current US$) of Egypt, Arab Rep. in 1976 to that in 1977?
Your response must be concise. 0.92. What is the ratio of the Aid received (current US$) of Israel in 1976 to that in 1977?
Offer a terse response. 0.81. What is the difference between the highest and the second highest Aid received (current US$) of Cameroon?
Your response must be concise. 4.44e+07. What is the difference between the highest and the second highest Aid received (current US$) of Egypt, Arab Rep.?
Keep it short and to the point. 1.27e+08. What is the difference between the highest and the second highest Aid received (current US$) in Israel?
Ensure brevity in your answer.  1.54e+08. What is the difference between the highest and the lowest Aid received (current US$) in Cameroon?
Offer a very short reply. 1.31e+08. What is the difference between the highest and the lowest Aid received (current US$) of Egypt, Arab Rep.?
Offer a very short reply. 2.51e+09. What is the difference between the highest and the lowest Aid received (current US$) in Israel?
Give a very brief answer. 7.34e+08. 